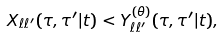Convert formula to latex. <formula><loc_0><loc_0><loc_500><loc_500>X _ { \ell \ell ^ { \prime } } ( \tau , \tau ^ { \prime } | t ) < Y ^ { ( \theta ) } _ { \ell \ell ^ { \prime } } ( \tau , \tau ^ { \prime } | t ) ,</formula> 